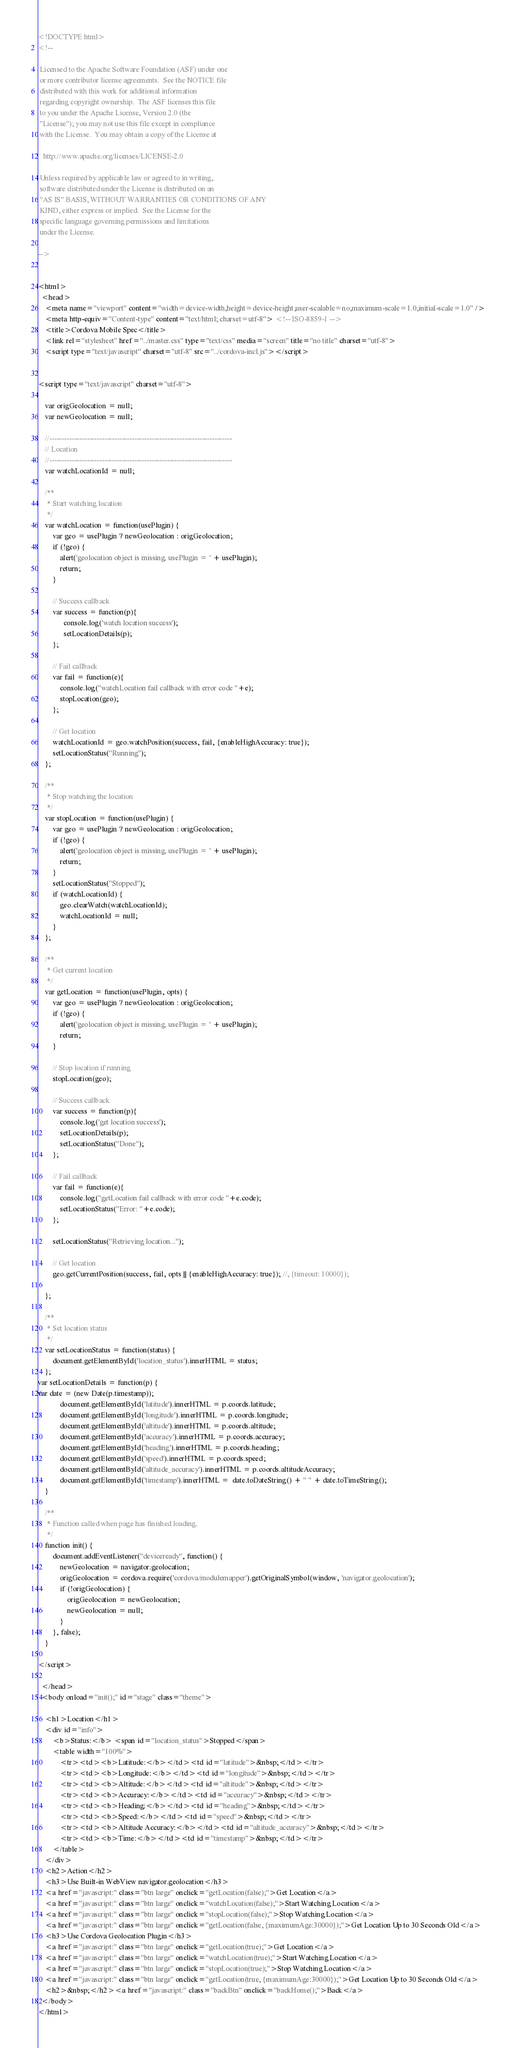Convert code to text. <code><loc_0><loc_0><loc_500><loc_500><_HTML_><!DOCTYPE html>
<!--

 Licensed to the Apache Software Foundation (ASF) under one
 or more contributor license agreements.  See the NOTICE file
 distributed with this work for additional information
 regarding copyright ownership.  The ASF licenses this file
 to you under the Apache License, Version 2.0 (the
 "License"); you may not use this file except in compliance
 with the License.  You may obtain a copy of the License at

   http://www.apache.org/licenses/LICENSE-2.0

 Unless required by applicable law or agreed to in writing,
 software distributed under the License is distributed on an
 "AS IS" BASIS, WITHOUT WARRANTIES OR CONDITIONS OF ANY
 KIND, either express or implied.  See the License for the
 specific language governing permissions and limitations
 under the License.

-->


<html>
  <head>
    <meta name="viewport" content="width=device-width,height=device-height,user-scalable=no,maximum-scale=1.0,initial-scale=1.0" />
    <meta http-equiv="Content-type" content="text/html; charset=utf-8"> <!-- ISO-8859-1 -->
    <title>Cordova Mobile Spec</title>
    <link rel="stylesheet" href="../master.css" type="text/css" media="screen" title="no title" charset="utf-8">
    <script type="text/javascript" charset="utf-8" src="../cordova-incl.js"></script>      

      
<script type="text/javascript" charset="utf-8">

    var origGeolocation = null;
    var newGeolocation = null;

    //-------------------------------------------------------------------------
    // Location
    //-------------------------------------------------------------------------
    var watchLocationId = null;

    /**
     * Start watching location
     */
    var watchLocation = function(usePlugin) {
        var geo = usePlugin ? newGeolocation : origGeolocation;
        if (!geo) {
            alert('geolocation object is missing. usePlugin = ' + usePlugin);
            return;
        }

        // Success callback
        var success = function(p){
              console.log('watch location success');
              setLocationDetails(p);
        };

        // Fail callback
        var fail = function(e){
            console.log("watchLocation fail callback with error code "+e);
            stopLocation(geo);
        };

        // Get location
        watchLocationId = geo.watchPosition(success, fail, {enableHighAccuracy: true});
        setLocationStatus("Running");
    };

    /**
     * Stop watching the location
     */
    var stopLocation = function(usePlugin) {
        var geo = usePlugin ? newGeolocation : origGeolocation;
        if (!geo) {
            alert('geolocation object is missing. usePlugin = ' + usePlugin);
            return;
        }
        setLocationStatus("Stopped");
        if (watchLocationId) {
            geo.clearWatch(watchLocationId);
            watchLocationId = null;
        }
    };

    /**
     * Get current location
     */
    var getLocation = function(usePlugin, opts) {
        var geo = usePlugin ? newGeolocation : origGeolocation;
        if (!geo) {
            alert('geolocation object is missing. usePlugin = ' + usePlugin);
            return;
        }

        // Stop location if running
        stopLocation(geo);

        // Success callback
        var success = function(p){
            console.log('get location success');
            setLocationDetails(p);
            setLocationStatus("Done");
        };

        // Fail callback
        var fail = function(e){
            console.log("getLocation fail callback with error code "+e.code);
            setLocationStatus("Error: "+e.code);
        };

        setLocationStatus("Retrieving location...");

        // Get location
        geo.getCurrentPosition(success, fail, opts || {enableHighAccuracy: true}); //, {timeout: 10000});

    };

    /**
     * Set location status
     */
    var setLocationStatus = function(status) {
        document.getElementById('location_status').innerHTML = status;
    };
var setLocationDetails = function(p) {
var date = (new Date(p.timestamp));
            document.getElementById('latitude').innerHTML = p.coords.latitude;
            document.getElementById('longitude').innerHTML = p.coords.longitude;
            document.getElementById('altitude').innerHTML = p.coords.altitude;
            document.getElementById('accuracy').innerHTML = p.coords.accuracy;
            document.getElementById('heading').innerHTML = p.coords.heading;
            document.getElementById('speed').innerHTML = p.coords.speed;
            document.getElementById('altitude_accuracy').innerHTML = p.coords.altitudeAccuracy;
            document.getElementById('timestamp').innerHTML =  date.toDateString() + " " + date.toTimeString();
    }
    
    /**
     * Function called when page has finished loading.
     */
    function init() {
        document.addEventListener("deviceready", function() {
            newGeolocation = navigator.geolocation;
            origGeolocation = cordova.require('cordova/modulemapper').getOriginalSymbol(window, 'navigator.geolocation');
            if (!origGeolocation) {
                origGeolocation = newGeolocation;
                newGeolocation = null;
            }
        }, false);
    }

</script>

  </head>
  <body onload="init();" id="stage" class="theme">
  
    <h1>Location</h1>
    <div id="info">
        <b>Status:</b> <span id="location_status">Stopped</span>
        <table width="100%">
            <tr><td><b>Latitude:</b></td><td id="latitude">&nbsp;</td></tr>
            <tr><td><b>Longitude:</b></td><td id="longitude">&nbsp;</td></tr>
            <tr><td><b>Altitude:</b></td><td id="altitude">&nbsp;</td></tr>
            <tr><td><b>Accuracy:</b></td><td id="accuracy">&nbsp;</td></tr>
            <tr><td><b>Heading:</b></td><td id="heading">&nbsp;</td></tr>
            <tr><td><b>Speed:</b></td><td id="speed">&nbsp;</td></tr>
            <tr><td><b>Altitude Accuracy:</b></td><td id="altitude_accuracy">&nbsp;</td></tr>
            <tr><td><b>Time:</b></td><td id="timestamp">&nbsp;</td></tr>
        </table>
    </div>
    <h2>Action</h2>
    <h3>Use Built-in WebView navigator.geolocation</h3>
    <a href="javascript:" class="btn large" onclick="getLocation(false);">Get Location</a>
    <a href="javascript:" class="btn large" onclick="watchLocation(false);">Start Watching Location</a>
    <a href="javascript:" class="btn large" onclick="stopLocation(false);">Stop Watching Location</a>
    <a href="javascript:" class="btn large" onclick="getLocation(false, {maximumAge:30000});">Get Location Up to 30 Seconds Old</a>
    <h3>Use Cordova Geolocation Plugin</h3>
    <a href="javascript:" class="btn large" onclick="getLocation(true);">Get Location</a>
    <a href="javascript:" class="btn large" onclick="watchLocation(true);">Start Watching Location</a>
    <a href="javascript:" class="btn large" onclick="stopLocation(true);">Stop Watching Location</a>
    <a href="javascript:" class="btn large" onclick="getLocation(true, {maximumAge:30000});">Get Location Up to 30 Seconds Old</a>
    <h2>&nbsp;</h2><a href="javascript:" class="backBtn" onclick="backHome();">Back</a>    
  </body>
</html>      
</code> 